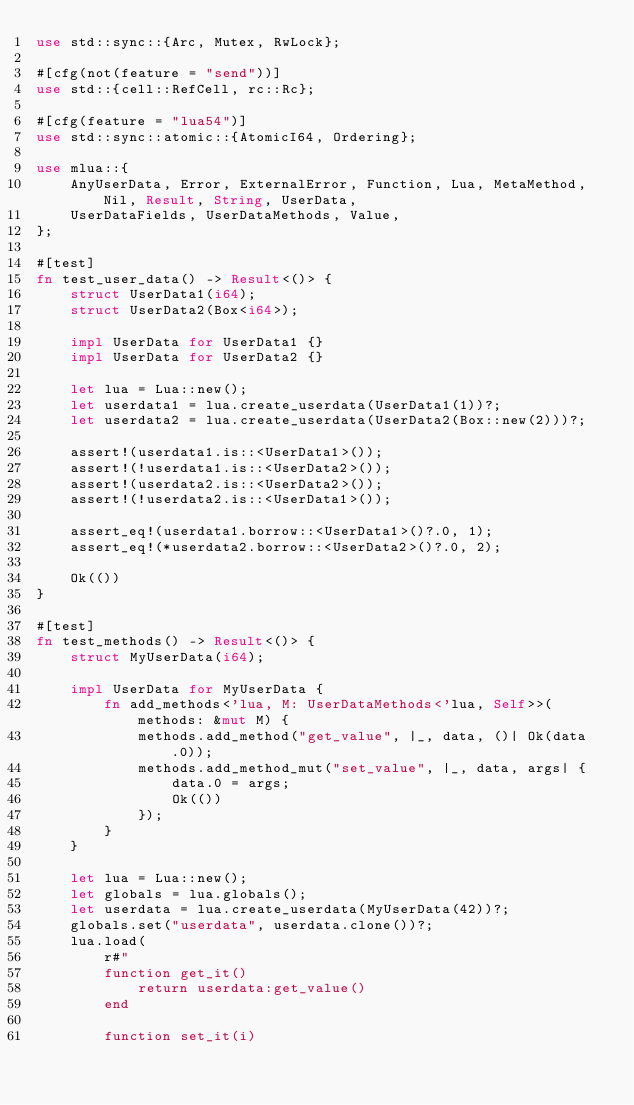Convert code to text. <code><loc_0><loc_0><loc_500><loc_500><_Rust_>use std::sync::{Arc, Mutex, RwLock};

#[cfg(not(feature = "send"))]
use std::{cell::RefCell, rc::Rc};

#[cfg(feature = "lua54")]
use std::sync::atomic::{AtomicI64, Ordering};

use mlua::{
    AnyUserData, Error, ExternalError, Function, Lua, MetaMethod, Nil, Result, String, UserData,
    UserDataFields, UserDataMethods, Value,
};

#[test]
fn test_user_data() -> Result<()> {
    struct UserData1(i64);
    struct UserData2(Box<i64>);

    impl UserData for UserData1 {}
    impl UserData for UserData2 {}

    let lua = Lua::new();
    let userdata1 = lua.create_userdata(UserData1(1))?;
    let userdata2 = lua.create_userdata(UserData2(Box::new(2)))?;

    assert!(userdata1.is::<UserData1>());
    assert!(!userdata1.is::<UserData2>());
    assert!(userdata2.is::<UserData2>());
    assert!(!userdata2.is::<UserData1>());

    assert_eq!(userdata1.borrow::<UserData1>()?.0, 1);
    assert_eq!(*userdata2.borrow::<UserData2>()?.0, 2);

    Ok(())
}

#[test]
fn test_methods() -> Result<()> {
    struct MyUserData(i64);

    impl UserData for MyUserData {
        fn add_methods<'lua, M: UserDataMethods<'lua, Self>>(methods: &mut M) {
            methods.add_method("get_value", |_, data, ()| Ok(data.0));
            methods.add_method_mut("set_value", |_, data, args| {
                data.0 = args;
                Ok(())
            });
        }
    }

    let lua = Lua::new();
    let globals = lua.globals();
    let userdata = lua.create_userdata(MyUserData(42))?;
    globals.set("userdata", userdata.clone())?;
    lua.load(
        r#"
        function get_it()
            return userdata:get_value()
        end

        function set_it(i)</code> 